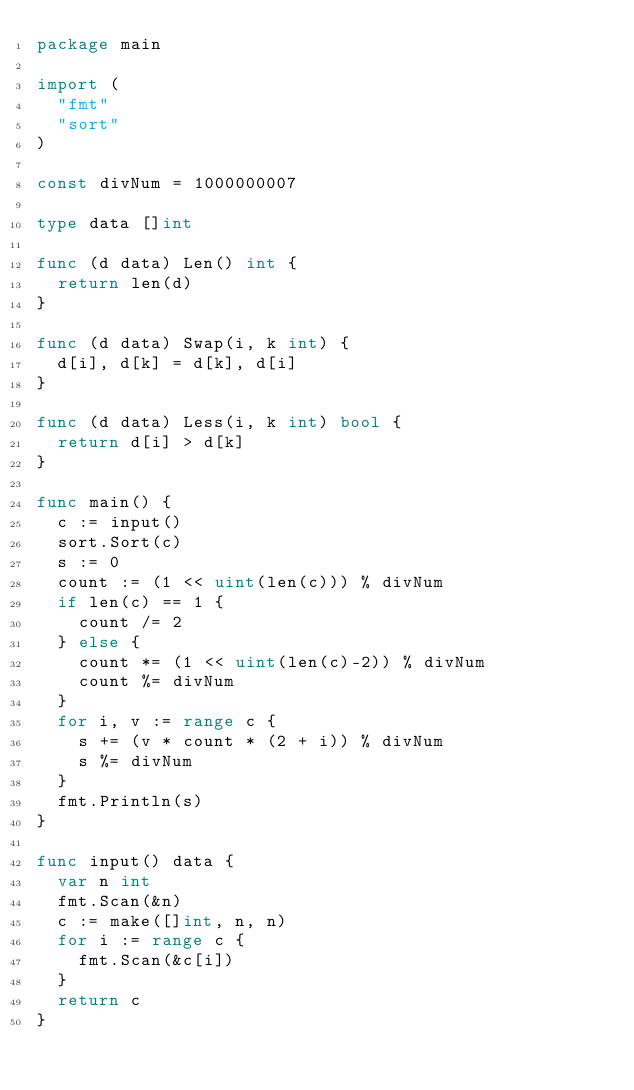<code> <loc_0><loc_0><loc_500><loc_500><_Go_>package main

import (
	"fmt"
	"sort"
)

const divNum = 1000000007

type data []int

func (d data) Len() int {
	return len(d)
}

func (d data) Swap(i, k int) {
	d[i], d[k] = d[k], d[i]
}

func (d data) Less(i, k int) bool {
	return d[i] > d[k]
}

func main() {
	c := input()
	sort.Sort(c)
	s := 0
	count := (1 << uint(len(c))) % divNum
	if len(c) == 1 {
		count /= 2
	} else {
		count *= (1 << uint(len(c)-2)) % divNum
		count %= divNum
	}
	for i, v := range c {
		s += (v * count * (2 + i)) % divNum
		s %= divNum
	}
	fmt.Println(s)
}

func input() data {
	var n int
	fmt.Scan(&n)
	c := make([]int, n, n)
	for i := range c {
		fmt.Scan(&c[i])
	}
	return c
}
</code> 